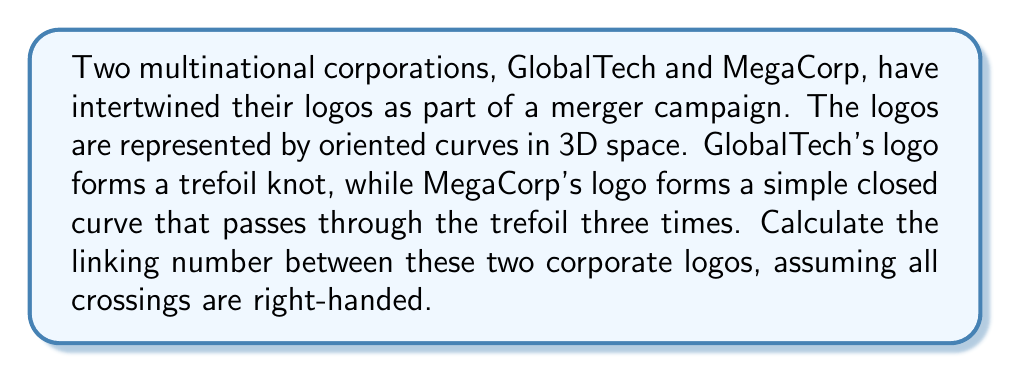Could you help me with this problem? To calculate the linking number between the two corporate logos, we'll follow these steps:

1. Identify the number of crossings:
   The MegaCorp logo passes through the GlobalTech trefoil three times, creating 6 crossings in total.

2. Determine the sign of each crossing:
   All crossings are given as right-handed, so each crossing contributes +1 to the linking number.

3. Apply the linking number formula:
   The linking number (Lk) is calculated as half the sum of the crossing signs.

   $$Lk = \frac{1}{2} \sum_{i=1}^{n} \epsilon_i$$

   Where $n$ is the number of crossings and $\epsilon_i$ is the sign of each crossing (+1 for right-handed, -1 for left-handed).

4. Calculate:
   $$Lk = \frac{1}{2} (1 + 1 + 1 + 1 + 1 + 1) = \frac{1}{2} (6) = 3$$

Therefore, the linking number between the GlobalTech and MegaCorp logos is 3.
Answer: 3 